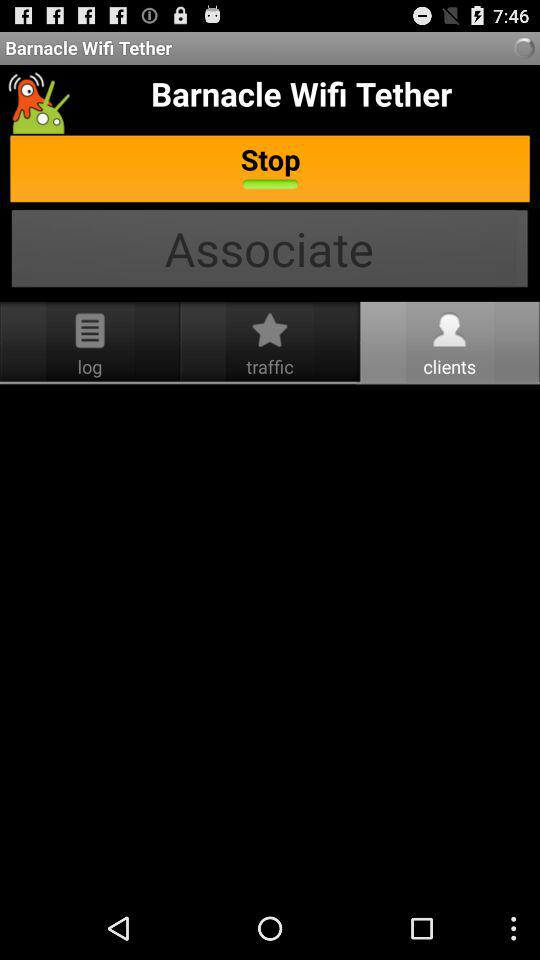What is the name of the application? The name of the application is "Barnacle Wifi Tether". 